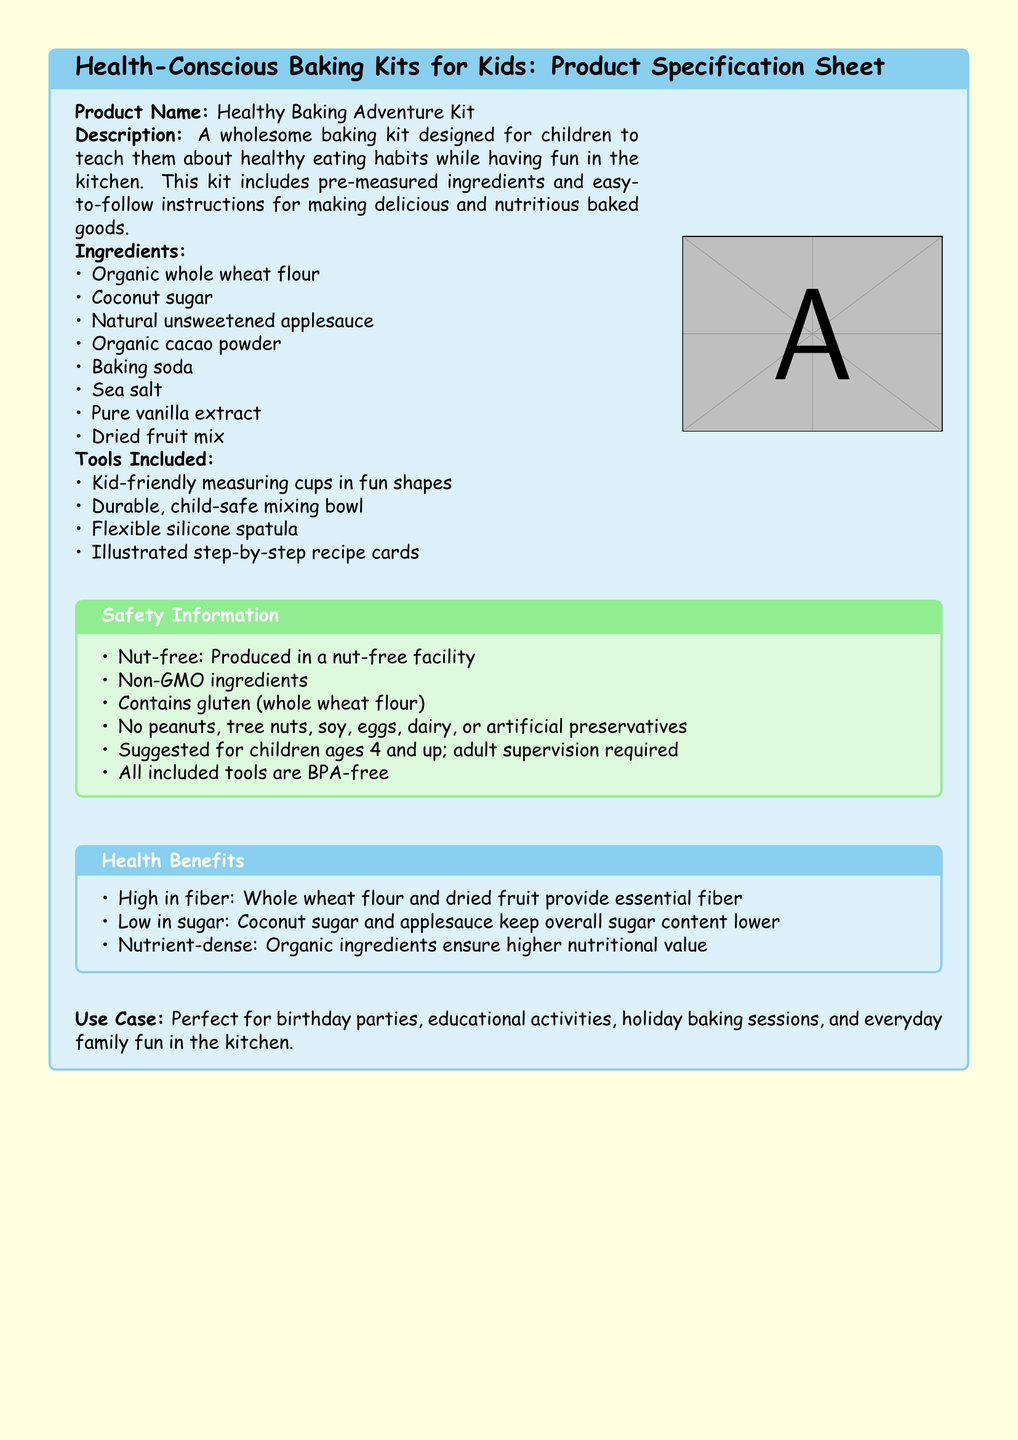What is the product name? The product name is stated clearly in the document.
Answer: Healthy Baking Adventure Kit How many ingredients are listed? The number of ingredients is assessed by counting the items in the ingredients list.
Answer: 8 What type of flour is used? The type of flour is specified in the list of ingredients.
Answer: Organic whole wheat flour Is this product nut-free? The safety information section indicates whether the product is nut-free or not.
Answer: Yes For what age group is the product suggested? The suggested age group is mentioned in the safety information section.
Answer: Ages 4 and up What ingredient keeps the sugar content low? The ingredient that helps maintain low sugar content is identified in the ingredient list.
Answer: Coconut sugar Are the tools included BPA-free? The safety information section mentions the safety of the tools included in the kit.
Answer: Yes What benefit does whole wheat flour provide? The health benefits section describes what whole wheat flour contributes to the baked goods.
Answer: High in fiber 